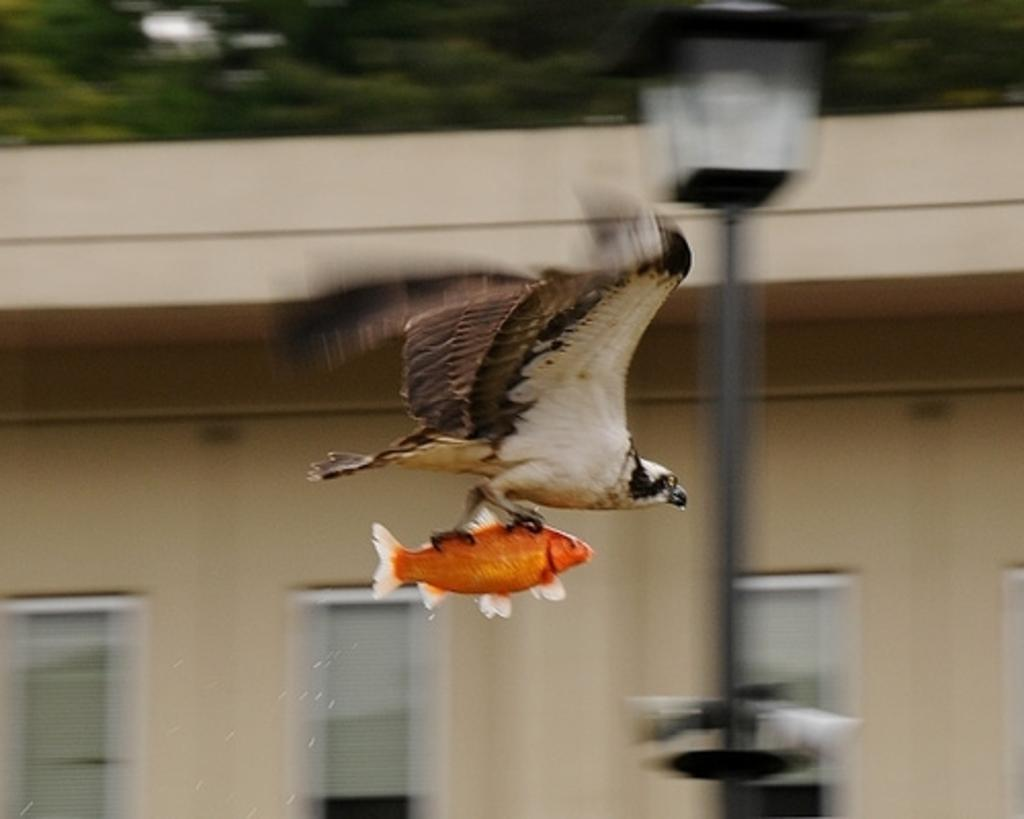What is the bird doing in the image? The bird is holding a fish in the image. What can be seen in the background of the image? There is a building and trees in the background of the image. Can you describe any other objects in the image? Yes, there is a street light in the image. What size key is used to unlock the door of the building in the image? There is no door or key present in the image; it only shows a bird holding a fish, a building in the background, a street light, and trees behind the building. 